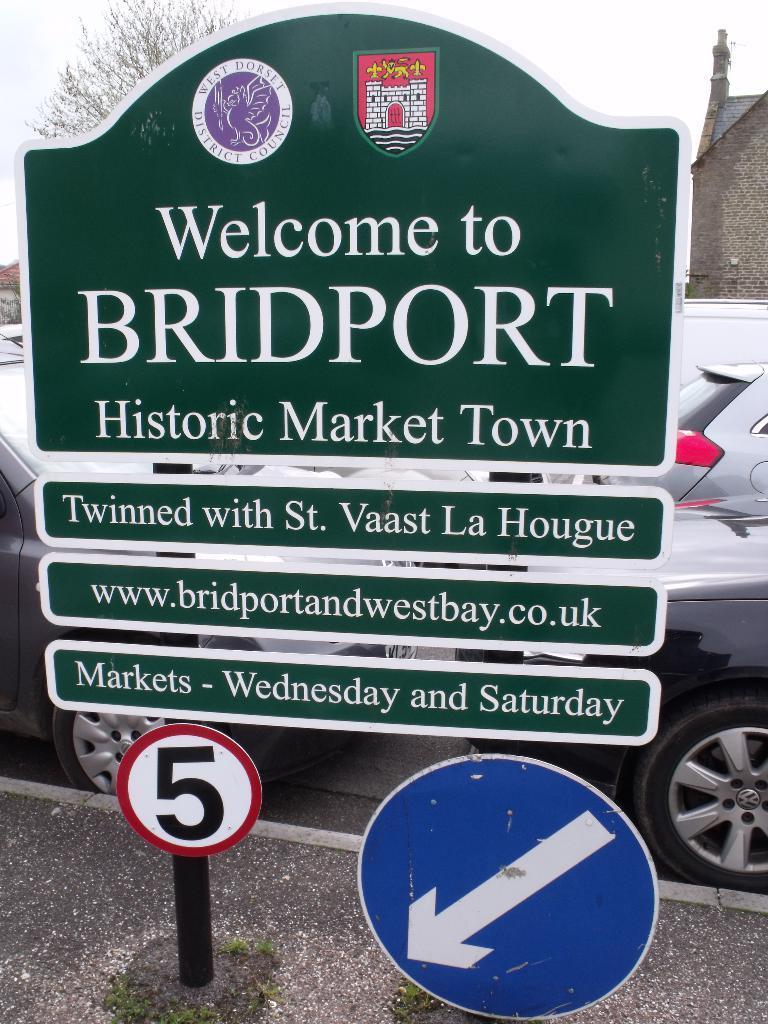Can you describe this image briefly? In this image I can see the sidewalk on which I can see two metal poles which are black in color to which few boards which are blue, white, red and green in color are attached. In the background I can see few cars on the road, few buildings, a tree and the sky. 